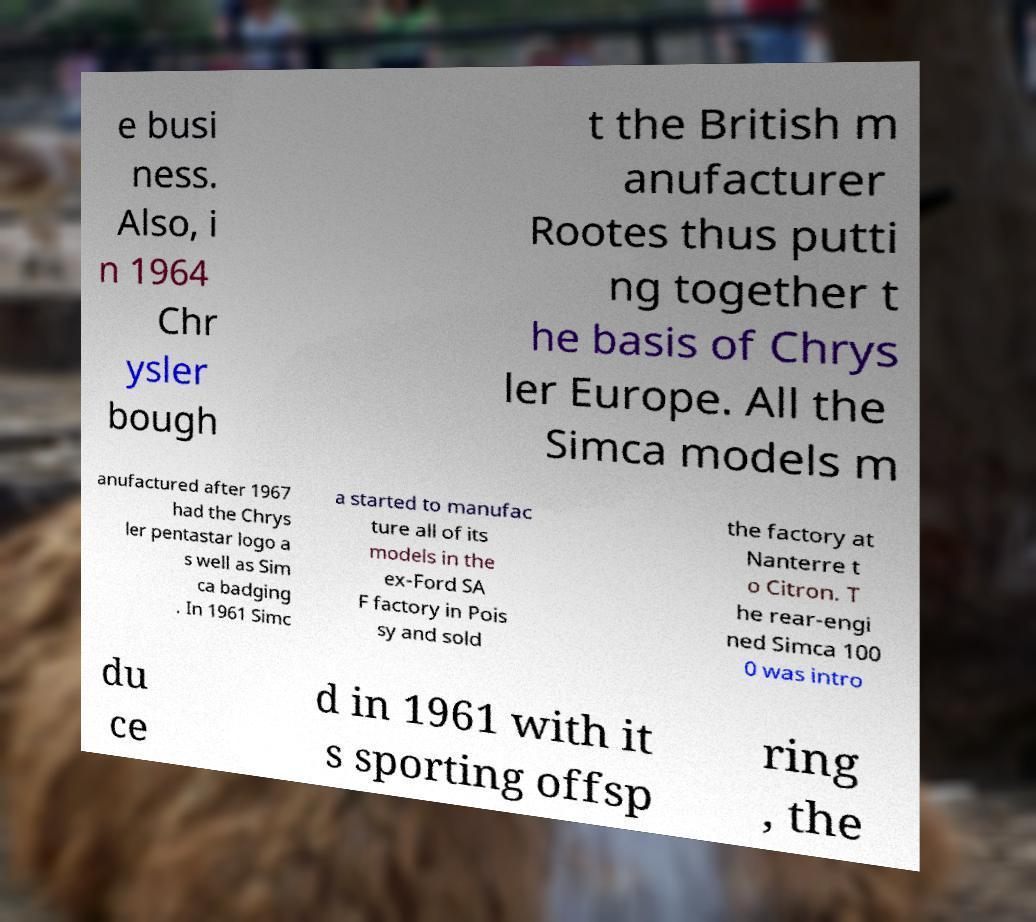There's text embedded in this image that I need extracted. Can you transcribe it verbatim? e busi ness. Also, i n 1964 Chr ysler bough t the British m anufacturer Rootes thus putti ng together t he basis of Chrys ler Europe. All the Simca models m anufactured after 1967 had the Chrys ler pentastar logo a s well as Sim ca badging . In 1961 Simc a started to manufac ture all of its models in the ex-Ford SA F factory in Pois sy and sold the factory at Nanterre t o Citron. T he rear-engi ned Simca 100 0 was intro du ce d in 1961 with it s sporting offsp ring , the 